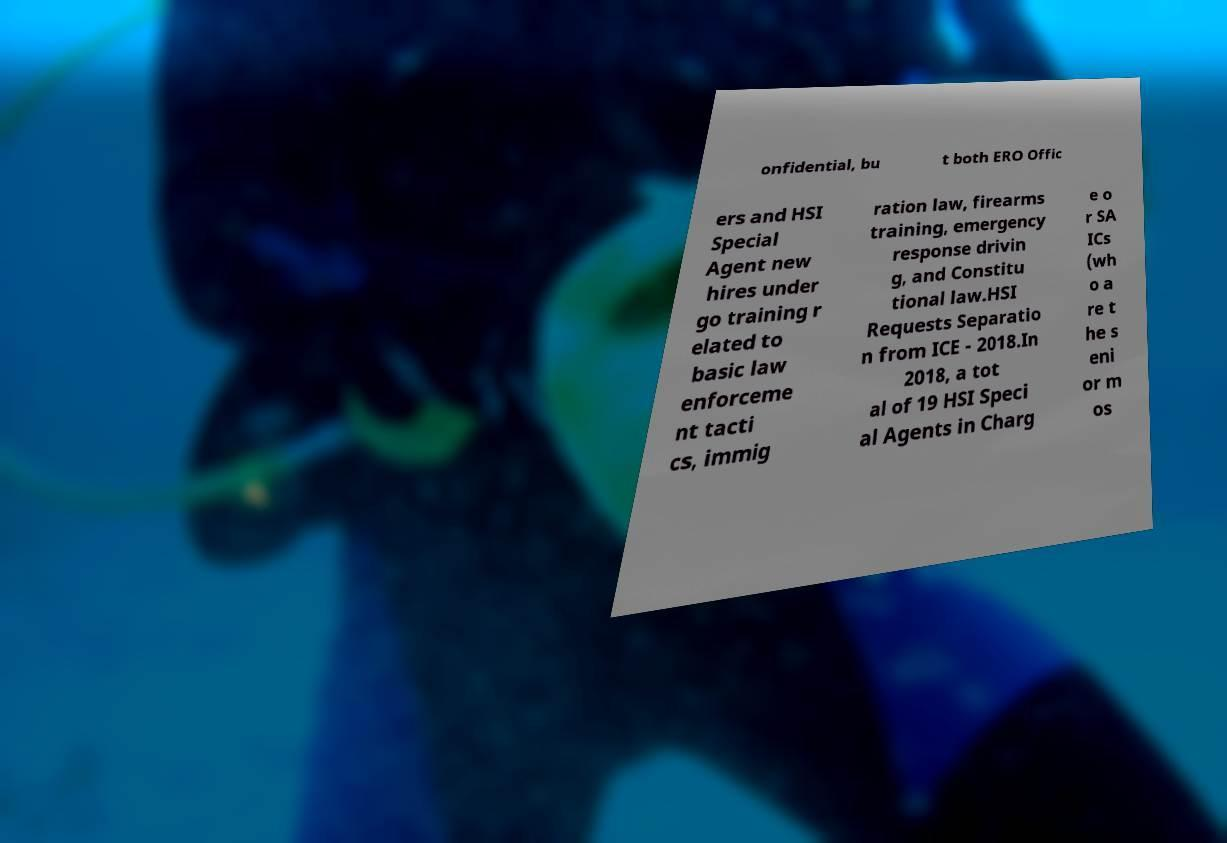I need the written content from this picture converted into text. Can you do that? onfidential, bu t both ERO Offic ers and HSI Special Agent new hires under go training r elated to basic law enforceme nt tacti cs, immig ration law, firearms training, emergency response drivin g, and Constitu tional law.HSI Requests Separatio n from ICE - 2018.In 2018, a tot al of 19 HSI Speci al Agents in Charg e o r SA ICs (wh o a re t he s eni or m os 